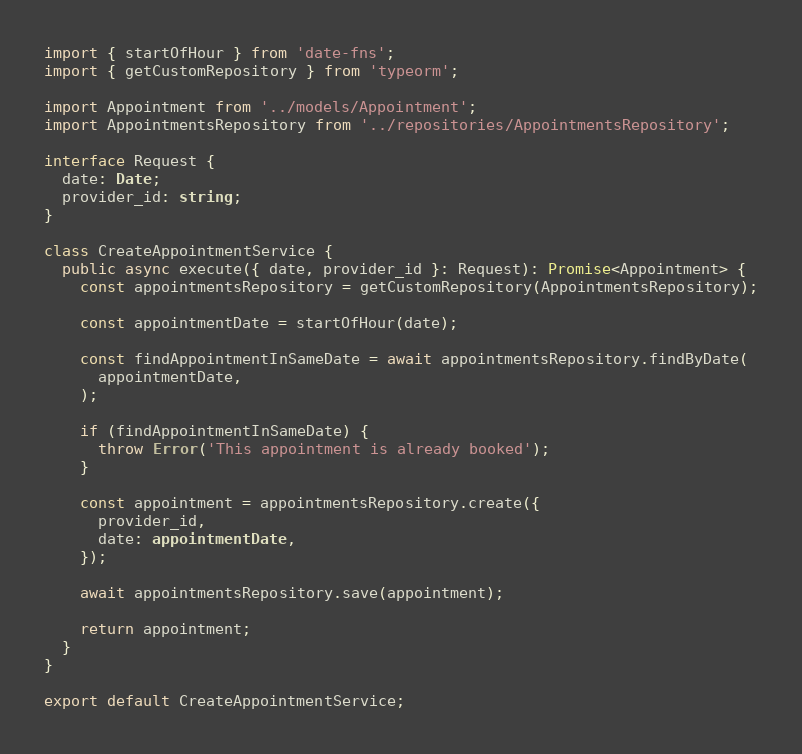<code> <loc_0><loc_0><loc_500><loc_500><_TypeScript_>import { startOfHour } from 'date-fns';
import { getCustomRepository } from 'typeorm';

import Appointment from '../models/Appointment';
import AppointmentsRepository from '../repositories/AppointmentsRepository';

interface Request {
  date: Date;
  provider_id: string;
}

class CreateAppointmentService {
  public async execute({ date, provider_id }: Request): Promise<Appointment> {
    const appointmentsRepository = getCustomRepository(AppointmentsRepository);

    const appointmentDate = startOfHour(date);

    const findAppointmentInSameDate = await appointmentsRepository.findByDate(
      appointmentDate,
    );

    if (findAppointmentInSameDate) {
      throw Error('This appointment is already booked');
    }

    const appointment = appointmentsRepository.create({
      provider_id,
      date: appointmentDate,
    });

    await appointmentsRepository.save(appointment);

    return appointment;
  }
}

export default CreateAppointmentService;
</code> 